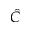<formula> <loc_0><loc_0><loc_500><loc_500>\hat { C }</formula> 